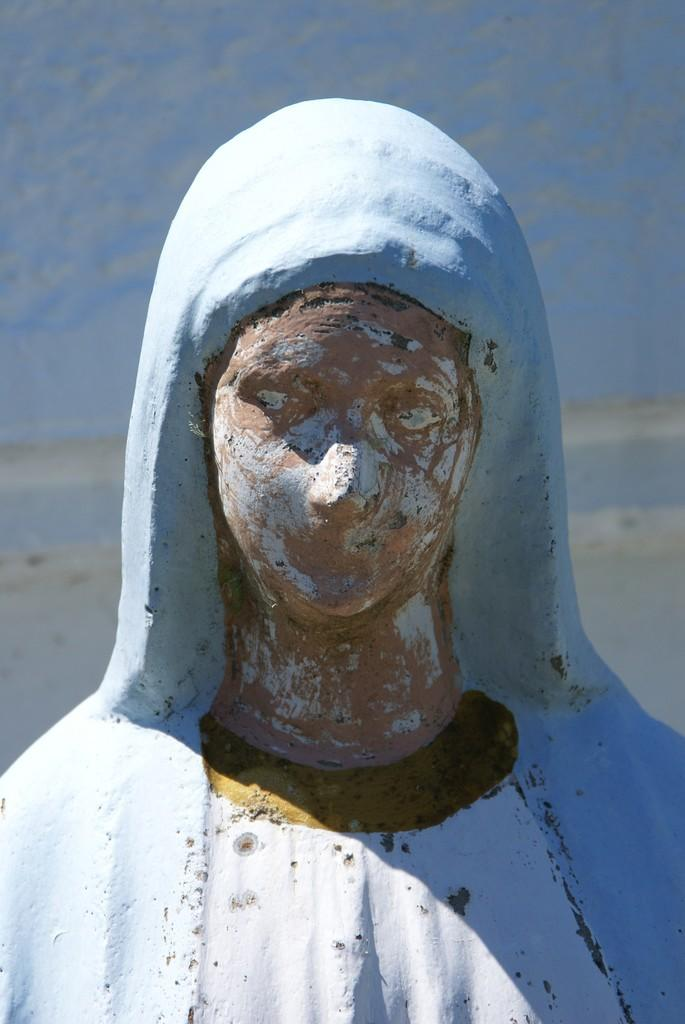Who is present in the image? There is a woman in the image. What is the woman wearing? The woman is wearing a blue dress. What color is the wall in the background of the image? There is a blue wall in the background of the image. What type of truck is visible in the image? There is no truck present in the image. What kind of doll is sitting on the woman's lap in the image? There is no doll present in the image. 